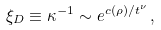<formula> <loc_0><loc_0><loc_500><loc_500>\xi _ { D } \equiv \kappa ^ { - 1 } \sim e ^ { c ( \rho ) / t ^ { \nu } } \, ,</formula> 